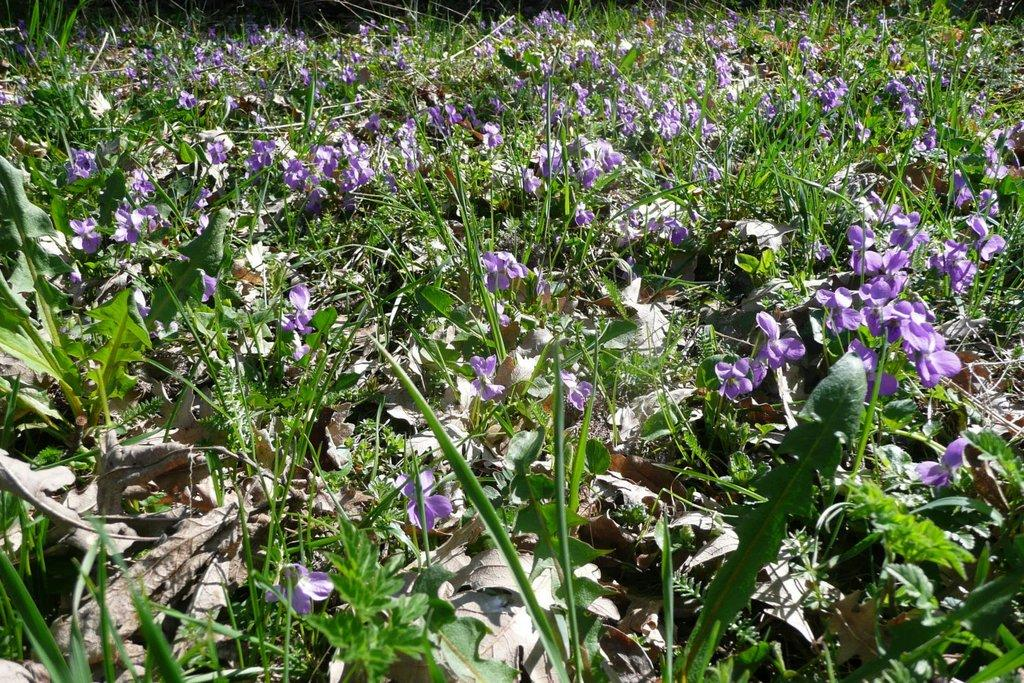What type of plant is visible in the image? There are flowers on the plant in the image. What can be found on the ground in the image? There are dry leaves on the ground in the image. How many chickens are running up the slope in the image? There are no chickens or slopes present in the image. What type of writing instrument is visible in the image? There is no writing instrument visible in the image. 